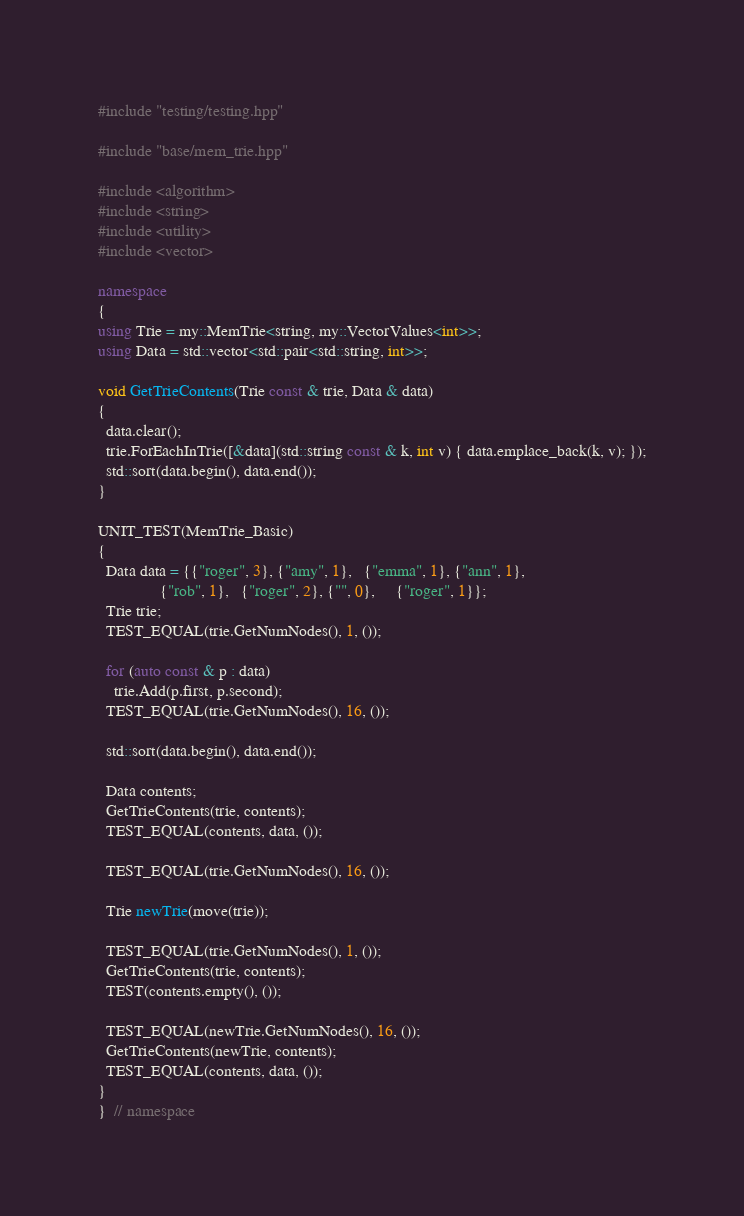Convert code to text. <code><loc_0><loc_0><loc_500><loc_500><_C++_>#include "testing/testing.hpp"

#include "base/mem_trie.hpp"

#include <algorithm>
#include <string>
#include <utility>
#include <vector>

namespace
{
using Trie = my::MemTrie<string, my::VectorValues<int>>;
using Data = std::vector<std::pair<std::string, int>>;

void GetTrieContents(Trie const & trie, Data & data)
{
  data.clear();
  trie.ForEachInTrie([&data](std::string const & k, int v) { data.emplace_back(k, v); });
  std::sort(data.begin(), data.end());
}

UNIT_TEST(MemTrie_Basic)
{
  Data data = {{"roger", 3}, {"amy", 1},   {"emma", 1}, {"ann", 1},
               {"rob", 1},   {"roger", 2}, {"", 0},     {"roger", 1}};
  Trie trie;
  TEST_EQUAL(trie.GetNumNodes(), 1, ());

  for (auto const & p : data)
    trie.Add(p.first, p.second);
  TEST_EQUAL(trie.GetNumNodes(), 16, ());

  std::sort(data.begin(), data.end());

  Data contents;
  GetTrieContents(trie, contents);
  TEST_EQUAL(contents, data, ());

  TEST_EQUAL(trie.GetNumNodes(), 16, ());

  Trie newTrie(move(trie));

  TEST_EQUAL(trie.GetNumNodes(), 1, ());
  GetTrieContents(trie, contents);
  TEST(contents.empty(), ());

  TEST_EQUAL(newTrie.GetNumNodes(), 16, ());
  GetTrieContents(newTrie, contents);
  TEST_EQUAL(contents, data, ());
}
}  // namespace
</code> 